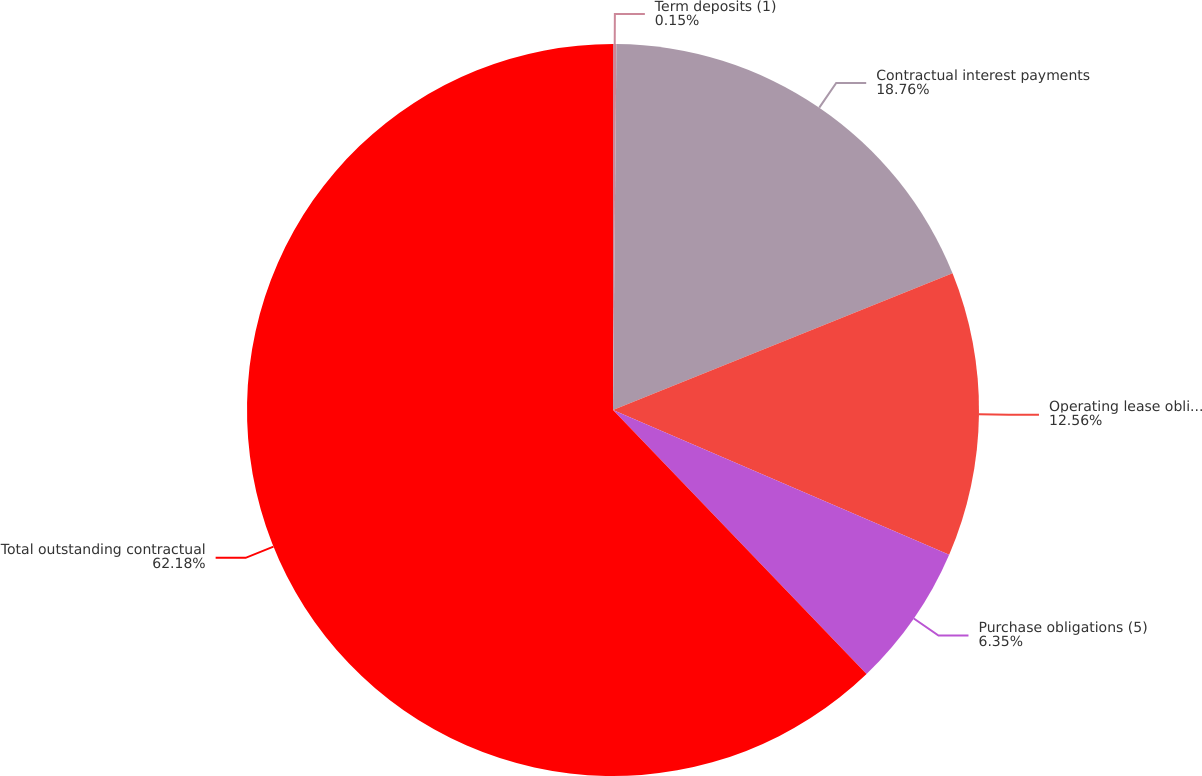Convert chart to OTSL. <chart><loc_0><loc_0><loc_500><loc_500><pie_chart><fcel>Term deposits (1)<fcel>Contractual interest payments<fcel>Operating lease obligations<fcel>Purchase obligations (5)<fcel>Total outstanding contractual<nl><fcel>0.15%<fcel>18.76%<fcel>12.56%<fcel>6.35%<fcel>62.18%<nl></chart> 